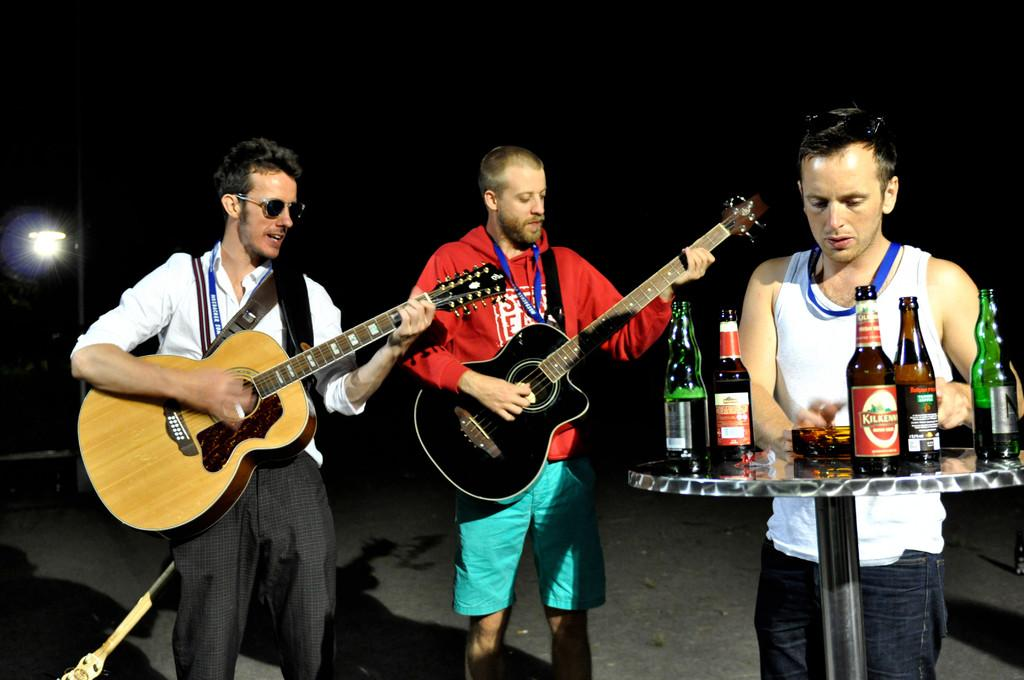How many men are present in the image? There are three men in the image. What are two of the men holding? Two of the men are holding guitars. What object can be seen in the image besides the men and guitars? There is a table in the image. What items are on the table? There are bottles on the table. What type of quilt is being used as a backdrop for the men in the image? There is no quilt present in the image; it features three men and a table with bottles. How many cars can be seen in the image? There are no cars visible in the image. 